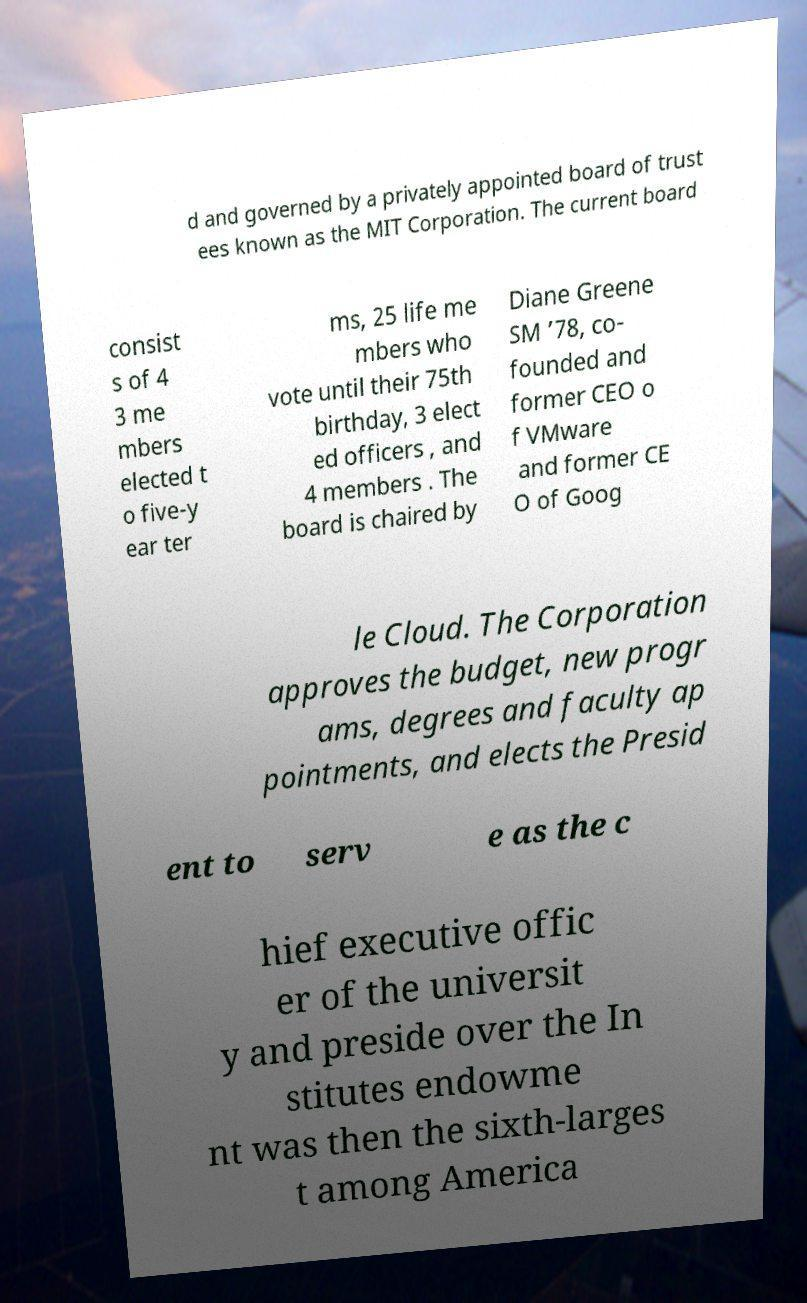Could you extract and type out the text from this image? d and governed by a privately appointed board of trust ees known as the MIT Corporation. The current board consist s of 4 3 me mbers elected t o five-y ear ter ms, 25 life me mbers who vote until their 75th birthday, 3 elect ed officers , and 4 members . The board is chaired by Diane Greene SM ’78, co- founded and former CEO o f VMware and former CE O of Goog le Cloud. The Corporation approves the budget, new progr ams, degrees and faculty ap pointments, and elects the Presid ent to serv e as the c hief executive offic er of the universit y and preside over the In stitutes endowme nt was then the sixth-larges t among America 